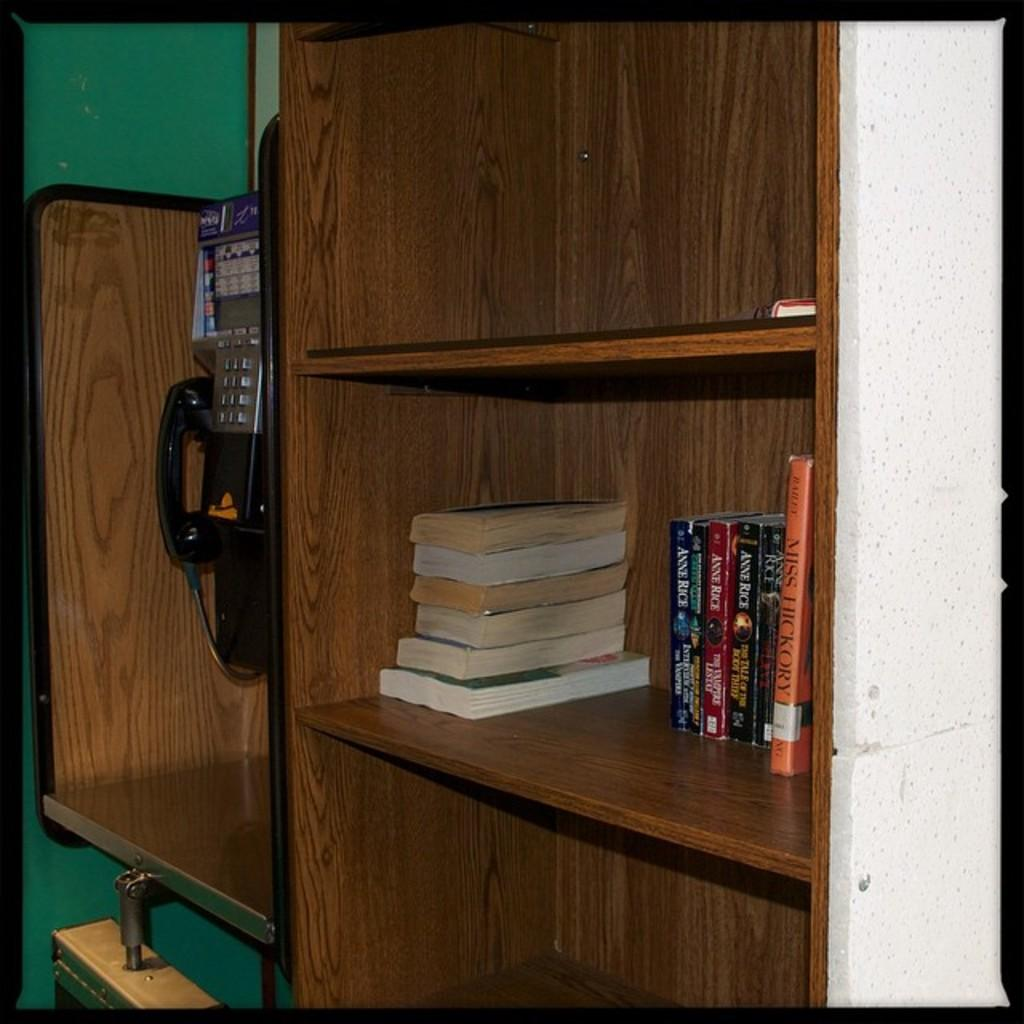What type of furniture is in the image? There is a wooden cupboard in the image. What is stored inside the cupboard? There are many books in the cupboard. Are there any other items in the cupboard besides books? Yes, there is a telephone in the cupboard. Can you see a group of snails crawling on the sidewalk in the image? There is no sidewalk or snails present in the image; it features a wooden cupboard with books and a telephone. 